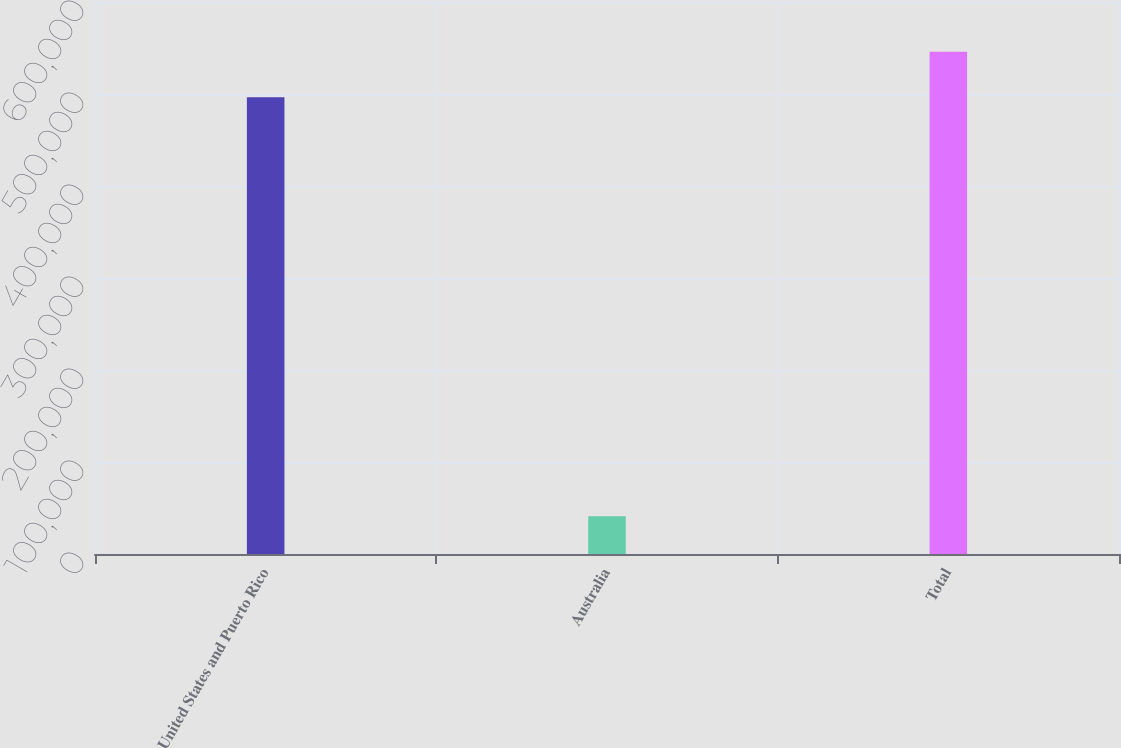Convert chart. <chart><loc_0><loc_0><loc_500><loc_500><bar_chart><fcel>United States and Puerto Rico<fcel>Australia<fcel>Total<nl><fcel>496368<fcel>41097<fcel>546005<nl></chart> 